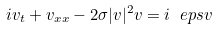Convert formula to latex. <formula><loc_0><loc_0><loc_500><loc_500>i v _ { t } + v _ { x x } - 2 \sigma | v | ^ { 2 } v = i \ e p s v</formula> 